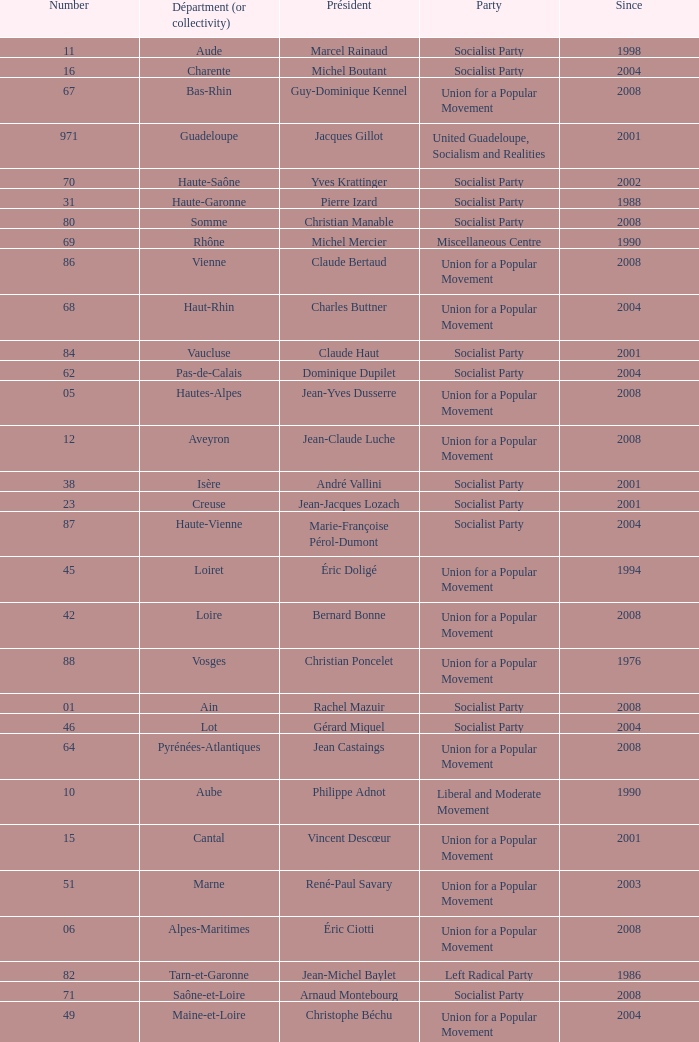Who is the president from the Union for a Popular Movement party that represents the Hautes-Alpes department? Jean-Yves Dusserre. 